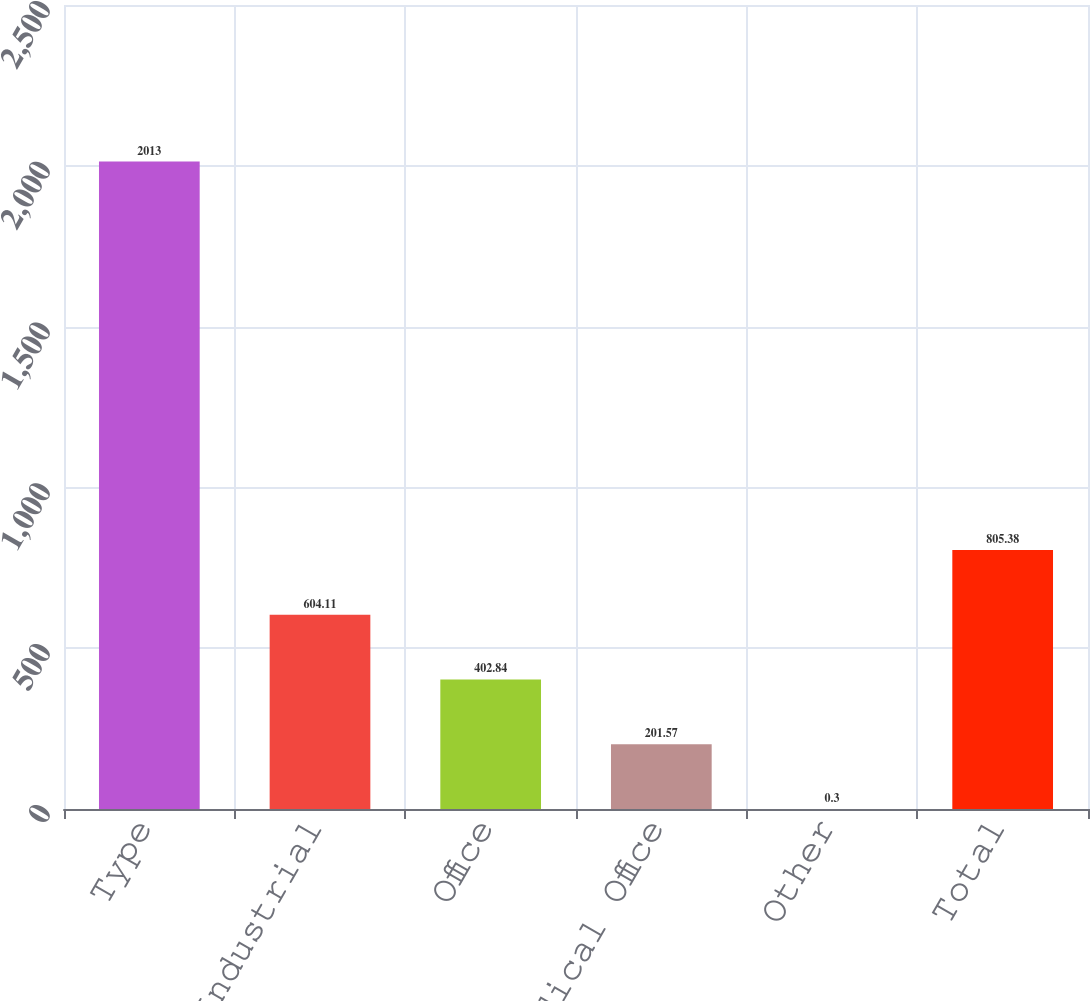Convert chart to OTSL. <chart><loc_0><loc_0><loc_500><loc_500><bar_chart><fcel>Type<fcel>Industrial<fcel>Office<fcel>Medical Office<fcel>Other<fcel>Total<nl><fcel>2013<fcel>604.11<fcel>402.84<fcel>201.57<fcel>0.3<fcel>805.38<nl></chart> 